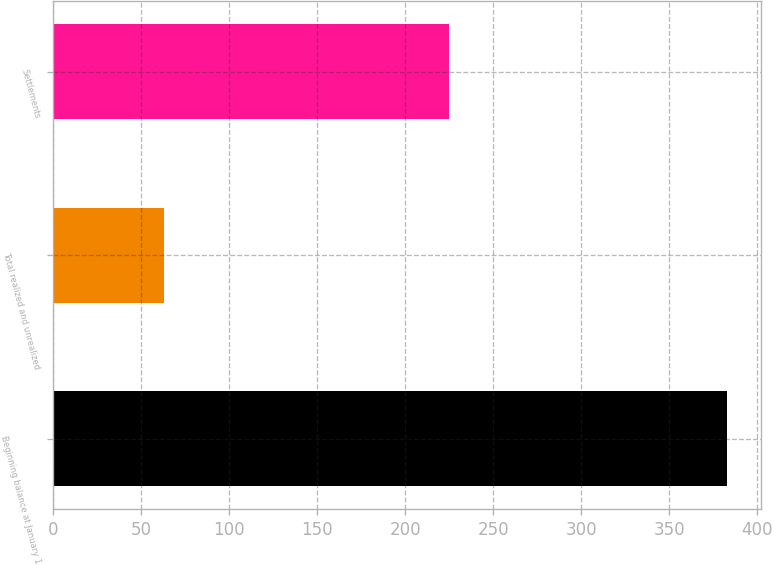<chart> <loc_0><loc_0><loc_500><loc_500><bar_chart><fcel>Beginning balance at January 1<fcel>Total realized and unrealized<fcel>Settlements<nl><fcel>383<fcel>63<fcel>225<nl></chart> 